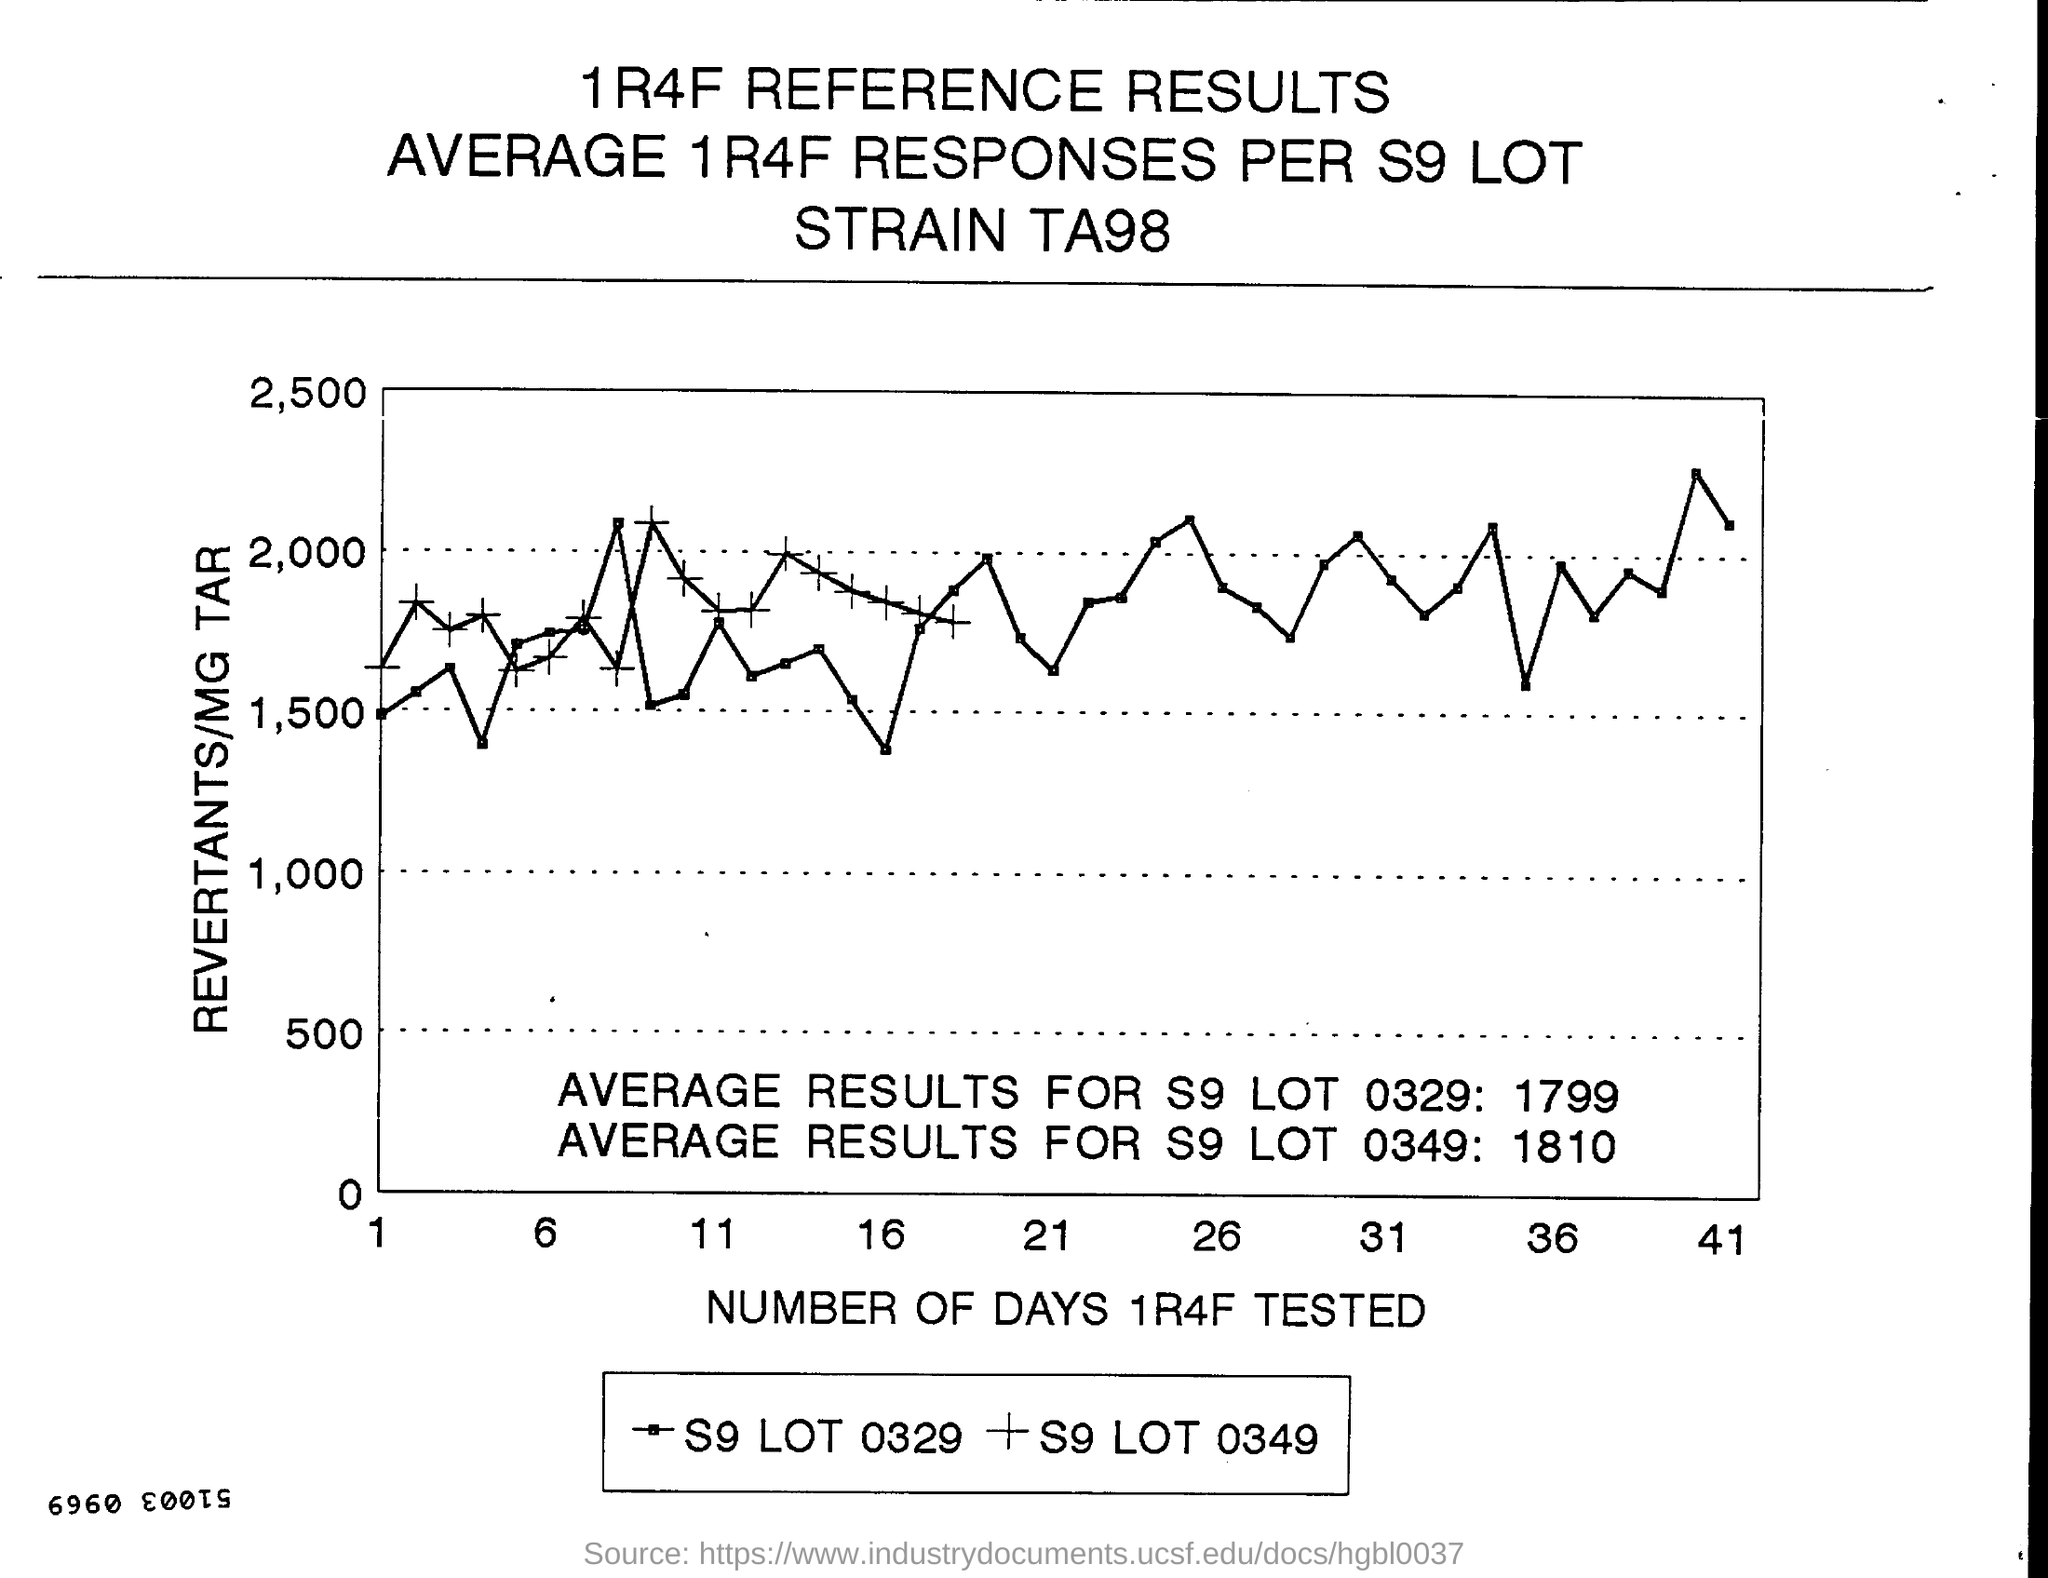What is represented along Y axis in the graph?
Offer a very short reply. Revertants/mg tar. What is represented along X axis in the graph?
Offer a terse response. Number of days 1r4f tested. What is the highest value written in the Y axis of the graph?
Provide a short and direct response. 2,500. What is the highest value written in the X axis of the graph?
Provide a succinct answer. 41. What is the lowest value written in the X axis of the graph?
Provide a succinct answer. 1. What is the lowest value written in the Y axis of the graph?
Keep it short and to the point. 0. What is the second highest value written in the X axis of the graph?
Ensure brevity in your answer.  36. What is the second highest value written in the Y axis of the graph?
Provide a short and direct response. 2000. 